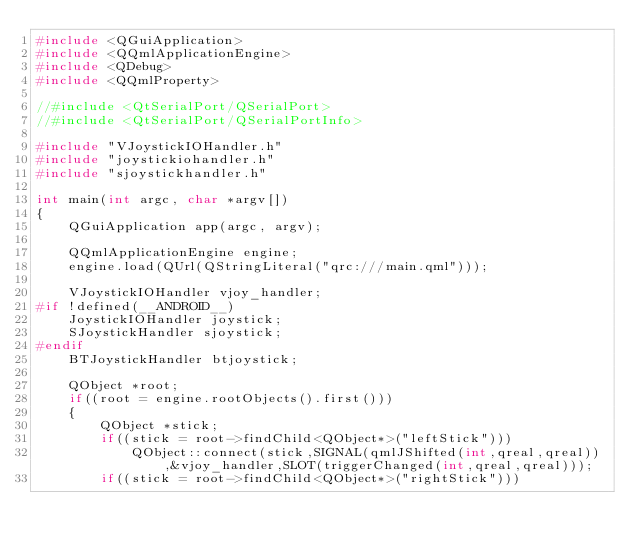<code> <loc_0><loc_0><loc_500><loc_500><_C++_>#include <QGuiApplication>
#include <QQmlApplicationEngine>
#include <QDebug>
#include <QQmlProperty>

//#include <QtSerialPort/QSerialPort>
//#include <QtSerialPort/QSerialPortInfo>

#include "VJoystickIOHandler.h"
#include "joystickiohandler.h"
#include "sjoystickhandler.h"

int main(int argc, char *argv[])
{
    QGuiApplication app(argc, argv);

    QQmlApplicationEngine engine;
    engine.load(QUrl(QStringLiteral("qrc:///main.qml")));

    VJoystickIOHandler vjoy_handler;
#if !defined(__ANDROID__)
    JoystickIOHandler joystick;
    SJoystickHandler sjoystick;
#endif
    BTJoystickHandler btjoystick;

    QObject *root;
    if((root = engine.rootObjects().first()))
    {
        QObject *stick;
        if((stick = root->findChild<QObject*>("leftStick")))
            QObject::connect(stick,SIGNAL(qmlJShifted(int,qreal,qreal)),&vjoy_handler,SLOT(triggerChanged(int,qreal,qreal)));
        if((stick = root->findChild<QObject*>("rightStick")))</code> 